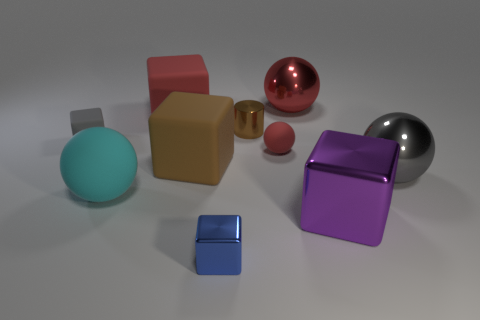What shape is the rubber thing that is the same color as the tiny shiny cylinder?
Provide a succinct answer. Cube. There is a rubber sphere on the left side of the large brown rubber cube; is its size the same as the shiny block in front of the purple metallic object?
Offer a very short reply. No. What is the shape of the big shiny object that is both in front of the red matte sphere and behind the purple block?
Offer a very short reply. Sphere. Is there a thing that has the same material as the gray block?
Give a very brief answer. Yes. There is a large block that is the same color as the small ball; what is it made of?
Your answer should be compact. Rubber. Is the material of the gray object on the right side of the tiny gray rubber block the same as the big ball that is on the left side of the metal cylinder?
Provide a short and direct response. No. Is the number of large spheres greater than the number of purple metal things?
Offer a very short reply. Yes. There is a metallic block that is on the left side of the shiny block that is behind the metal block on the left side of the large red shiny sphere; what is its color?
Provide a short and direct response. Blue. Is the color of the large shiny ball on the right side of the large red metal thing the same as the small cube behind the gray metallic object?
Your answer should be compact. Yes. There is a tiny block that is in front of the big brown block; what number of blocks are on the right side of it?
Make the answer very short. 1. 